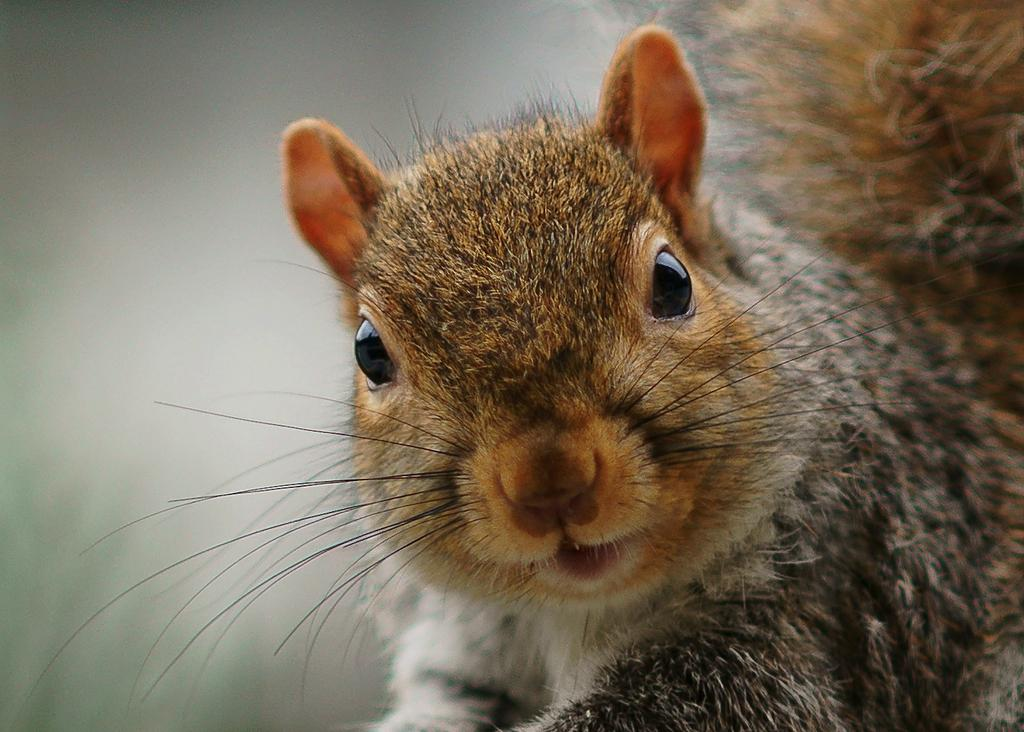What type of animal is in the image? There is a fox squirrel in the image. Can you describe the lighting in the image? There is darkness in the top left corner of the image. What type of pencil is being used to draw the fox squirrel in the image? There is no pencil or drawing present in the image; it is a photograph of a fox squirrel. 